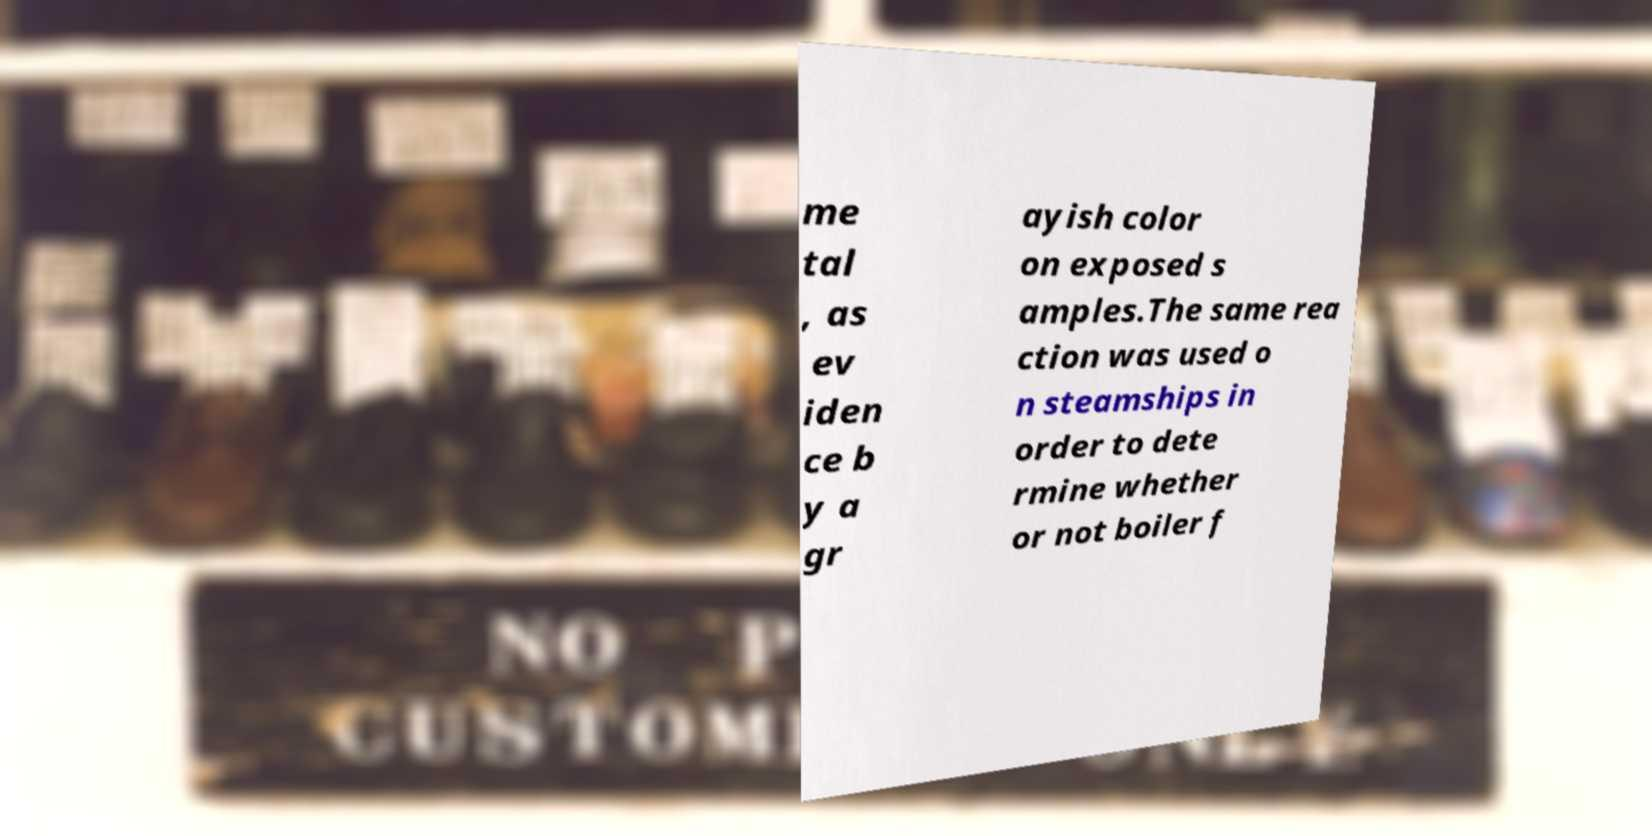What messages or text are displayed in this image? I need them in a readable, typed format. me tal , as ev iden ce b y a gr ayish color on exposed s amples.The same rea ction was used o n steamships in order to dete rmine whether or not boiler f 